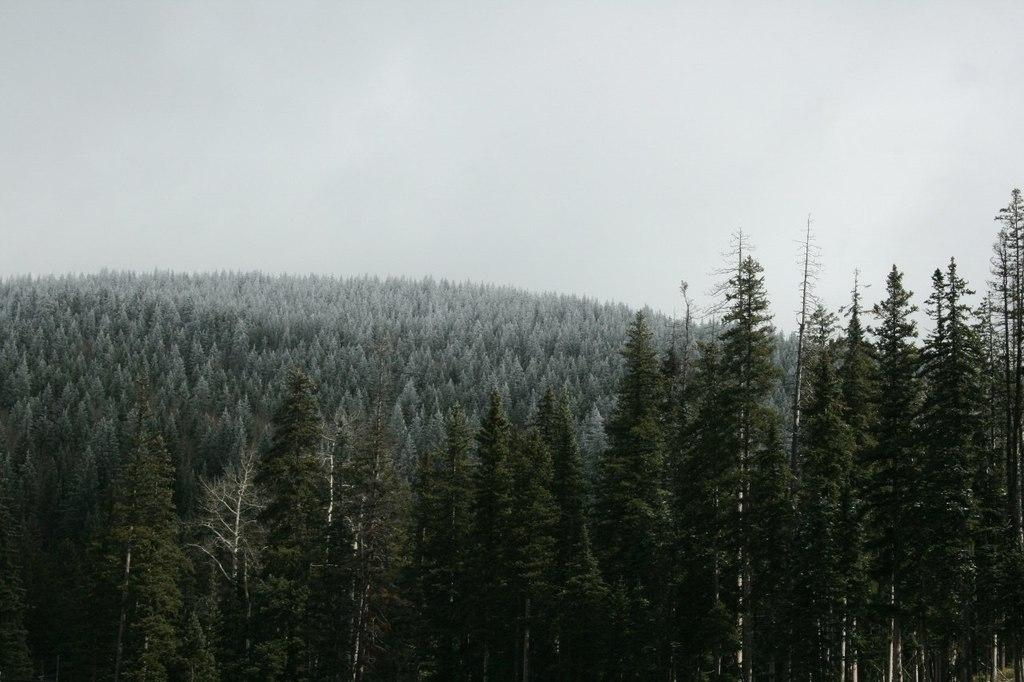Where was the image taken? The image was taken outdoors. What can be seen in the sky in the image? The sky with clouds is visible at the top of the image. What is the main feature in the middle of the image? There are many trees in the middle of the image. Can you describe the trees in the image? The trees have leaves, stems, and branches. How many dogs are sitting on the branches of the trees in the image? There are no dogs present in the image; it only features trees with leaves, stems, and branches. Is there an airplane flying in the sky in the image? The image does not show an airplane in the sky; only clouds are visible. 